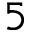<formula> <loc_0><loc_0><loc_500><loc_500>5</formula> 